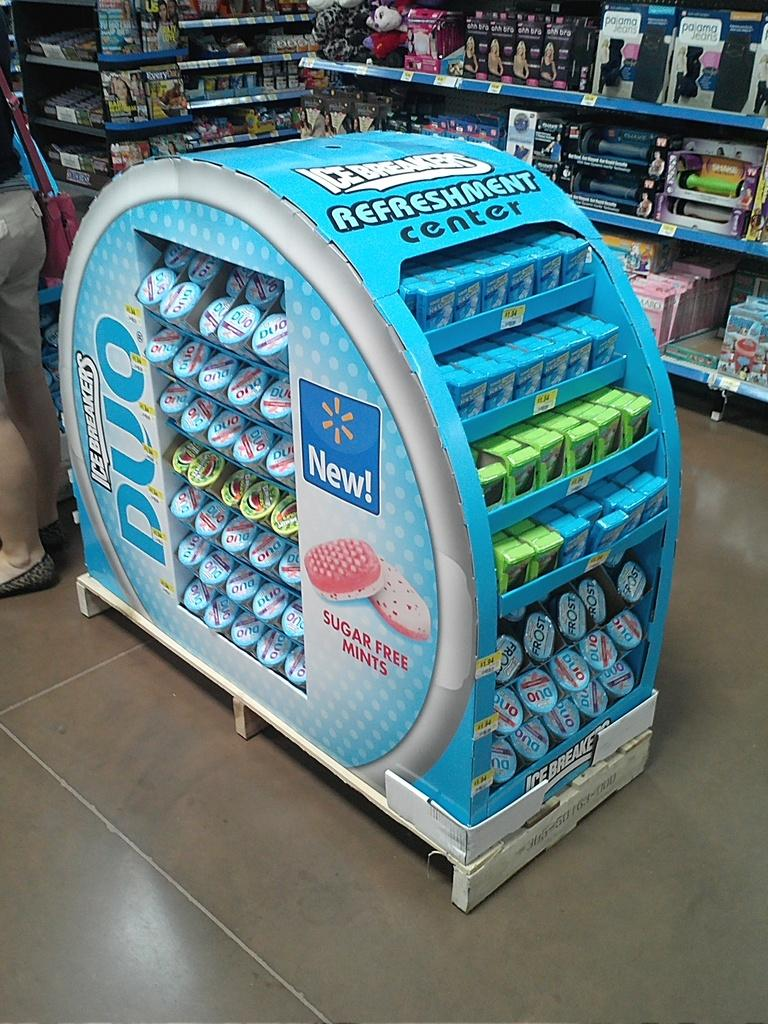<image>
Present a compact description of the photo's key features. a refreshment center located in a wal mart store 